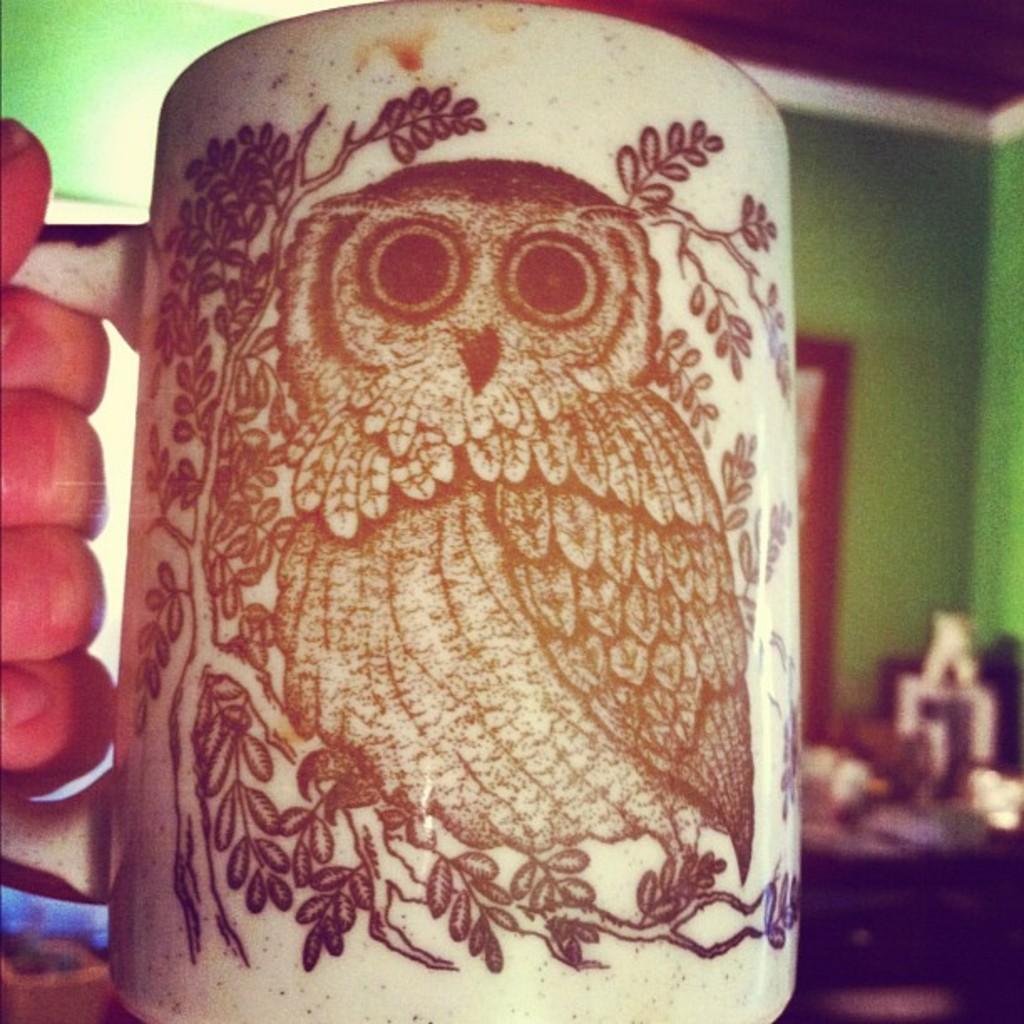Describe this image in one or two sentences. In this image we can see a human hand is holding a cup. In the background, we can see the wall and the roof. On the right side of the image we can see some objects. 